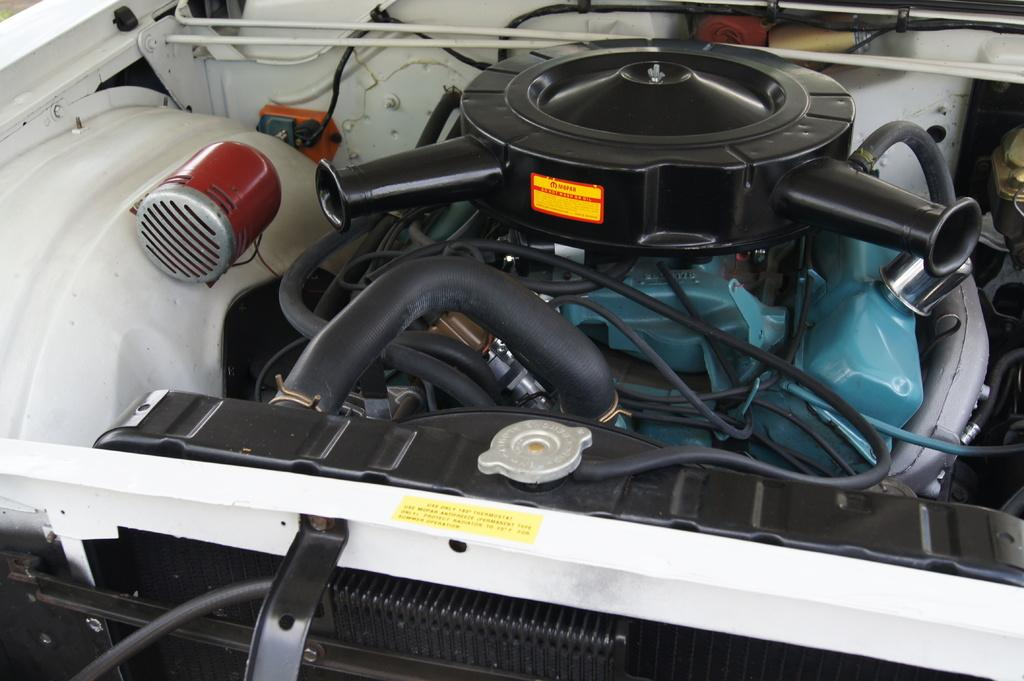What type of objects are visible in the image? There are machines in the image. What part of a vehicle can be seen in the image? The image appears to show the front part of a car. Are there any labels or markings on the machines? Yes, there is a label on one of the machines. What information is provided on the label? There is text on the label. Is there any blood visible on the car in the image? No, there is no blood visible in the image. What type of crime might be taking place in the image? There is no indication of any crime in the image. 